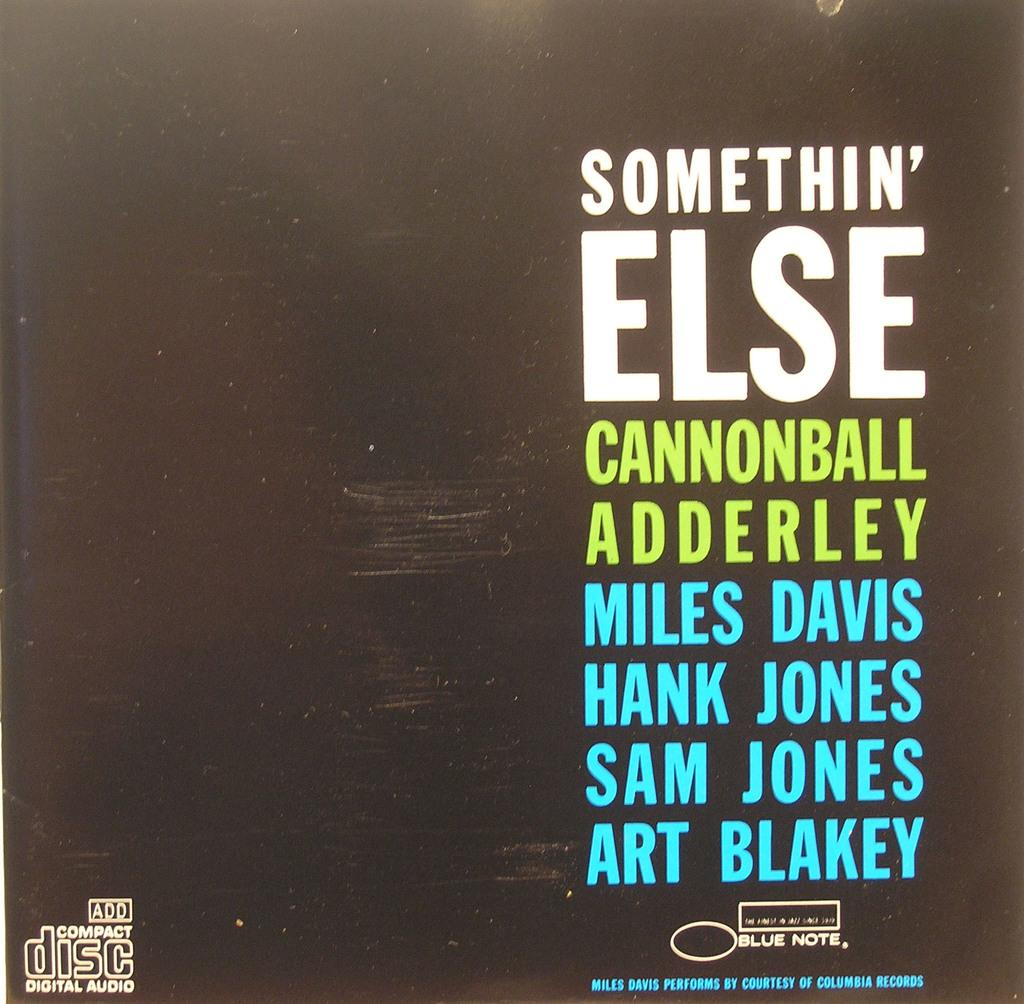<image>
Give a short and clear explanation of the subsequent image. A compact disc of musical artists including Miles Davis. 